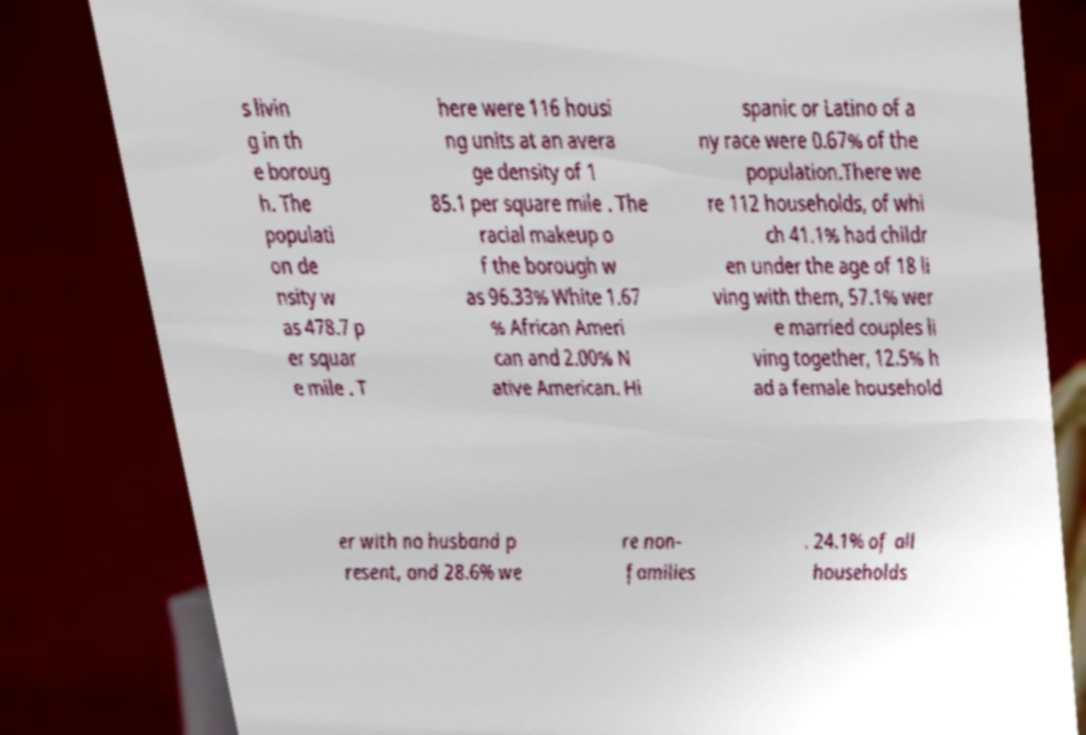I need the written content from this picture converted into text. Can you do that? s livin g in th e boroug h. The populati on de nsity w as 478.7 p er squar e mile . T here were 116 housi ng units at an avera ge density of 1 85.1 per square mile . The racial makeup o f the borough w as 96.33% White 1.67 % African Ameri can and 2.00% N ative American. Hi spanic or Latino of a ny race were 0.67% of the population.There we re 112 households, of whi ch 41.1% had childr en under the age of 18 li ving with them, 57.1% wer e married couples li ving together, 12.5% h ad a female household er with no husband p resent, and 28.6% we re non- families . 24.1% of all households 